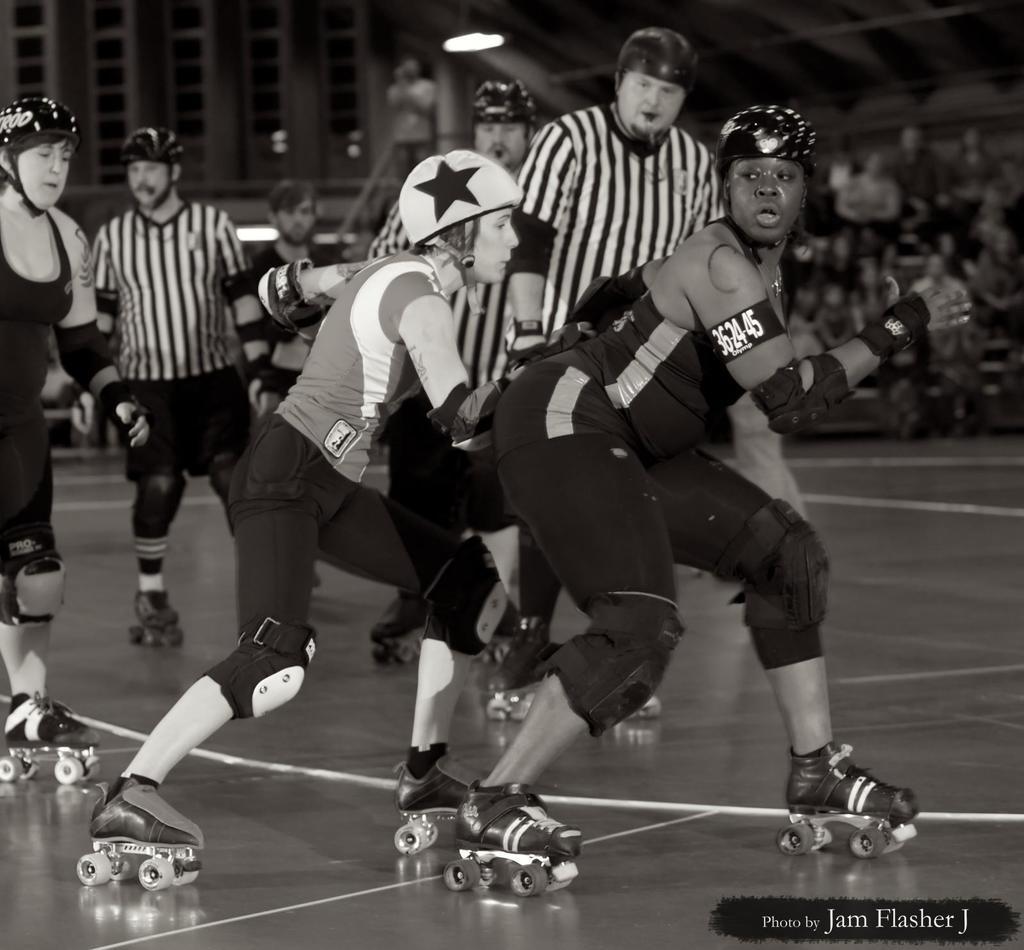Describe this image in one or two sentences. In this image we can see some group of persons wearing helmets, knee pads, elbow pads doing skating on the skating rink and at the background of the image there are some spectators and referees. 